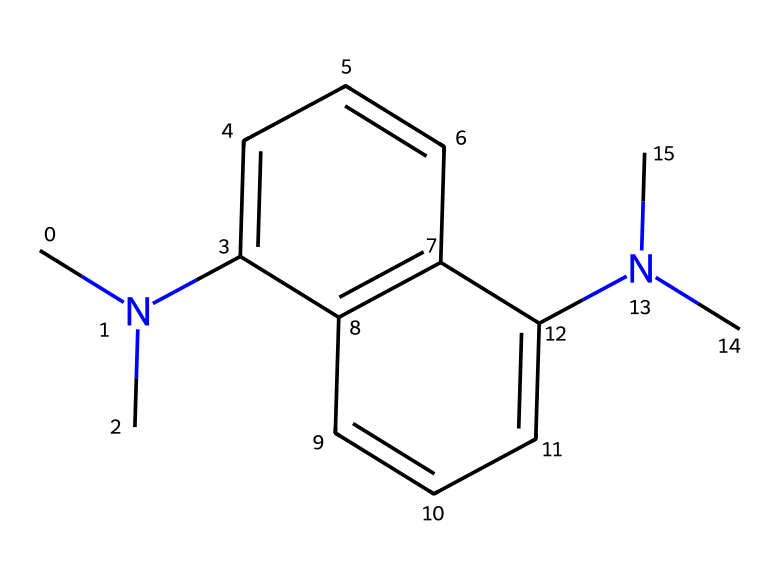What is the total number of carbon atoms in this molecule? The SMILES representation indicates the presence of carbon atoms (C). By analyzing the structure, I can count each carbon in the rings and chains. There are 14 carbon atoms present in the structure.
Answer: 14 How many nitrogen atoms are there in the structure? In the provided SMILES, nitrogen atoms (N) are also explicitly represented. I can see that there are 2 nitrogen atoms present based on their positions in the structure.
Answer: 2 What type of molecular structure does this superbase exhibit? The presence of multiple aromatic rings and substituents indicates that this compound is planar. Additionally, the nitrogen atoms imply it is a proton sponge, commonly characterized by aromatic and nitrogen-containing motifs.
Answer: planar What is the primary role of nitrogen atoms in this molecule? The nitrogen atoms in the structure provide basicity, allowing the molecule to act as a strong proton sponge because they can readily accept protons. Their arrangement enhances this capability significantly.
Answer: basicity Which characteristic feature aids in the strong basicity of this superbase? The presence of the nitrogen atoms in conjunction with the aromatic rings allows for effective delocalization of charge. This stabilizes the molecule upon protonation, thereby increasing its basicity.
Answer: delocalization 